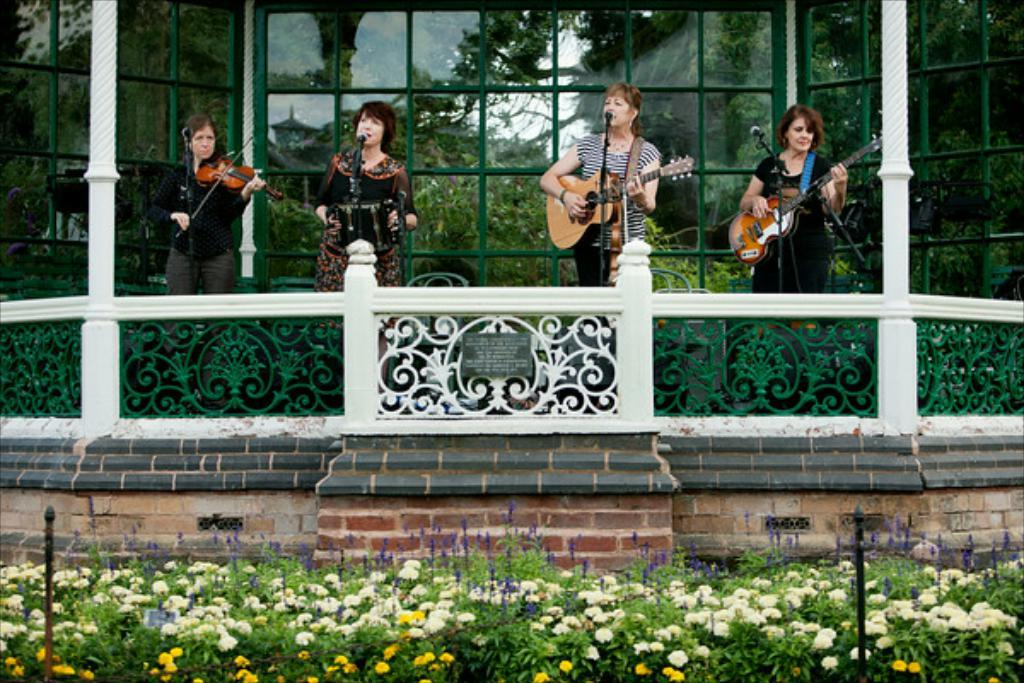What is happening in the image involving a group of women? The women in the image are playing musical instruments. What is present in front of the women? There is a microphone in front of the women. What can be seen on the ground in the image? There are flower plants on the ground. How many spots are visible on the women's clothing in the image? There is no mention of spots on the women's clothing in the image, so we cannot determine the number of spots. 